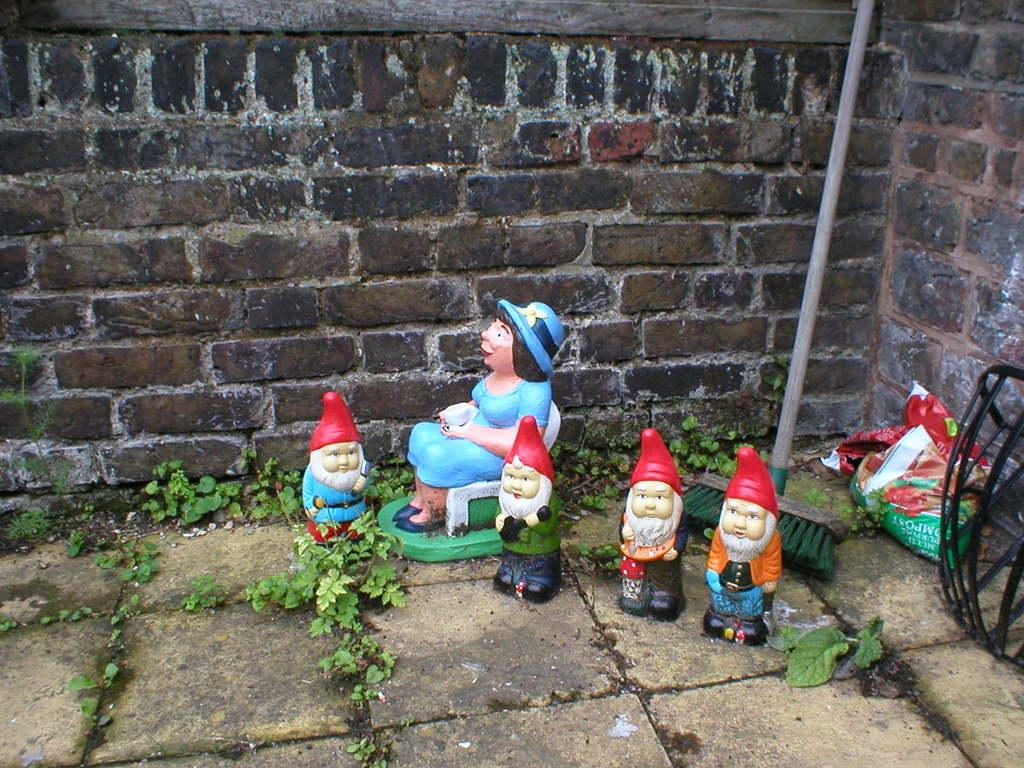What type of objects can be seen in the image? There are many toys in the image. What tool is present for cleaning purposes? There is a cleaning stick in the image. What type of natural environment is visible in the image? There is grass visible in the image. What type of surface is present in the image? There is a floor in the image. What type of structure is visible in the image? There is a brick wall in the image. What type of legal advice can be sought from the toys in the image? The toys in the image do not provide legal advice, as they are inanimate objects. 